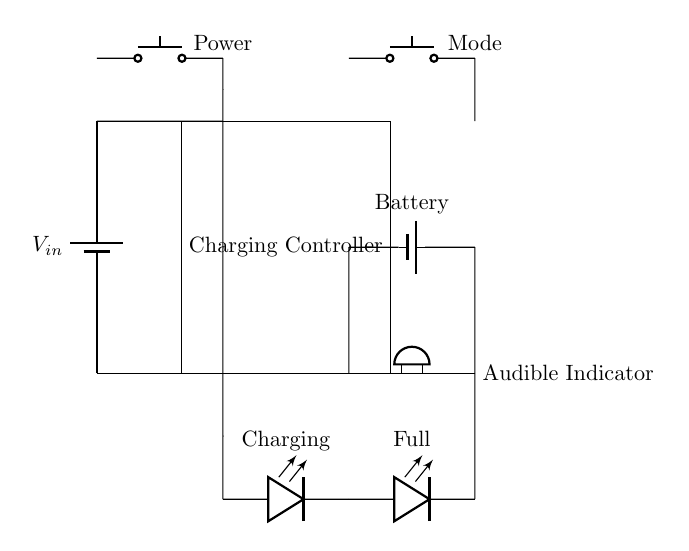What type of power supply is used in this circuit? The circuit uses a battery as its power supply, which is indicated by the symbol labeled as $V_{in}$. A battery provides the necessary voltage and current to charge the hearing aid battery.
Answer: battery How many buttons are present in the circuit? There are two push buttons in the circuit, one labeled as Power and the other labeled as Mode, both located at the top of the diagram.
Answer: two What function does the buzzer serve in this circuit? The buzzer acts as an audible indicator, providing sound feedback regarding the charging status of the battery. Its presence shows that there is an active component to alert the user with sound.
Answer: audible indicator What do the LED indicators represent? The two LED indicators labeled as Charging and Full indicate the status of the battery charging process. The 'Charging' LED lights up when the battery is charging, while the 'Full' LED lights up when the battery is fully charged.
Answer: Charging and Full Which component regulates the charging process? The component that regulates the charging process is the Charging Controller, which manages the flow of electricity from the power supply to the battery, ensuring that it charges safely and effectively.
Answer: Charging Controller What connects the battery to the audible indicator? The battery is connected to the audible indicator through conductive paths shown in the diagram, indicating that it receives power directly from the battery. This connection allows the buzzer to operate whenever needed for alerts.
Answer: conductive paths What does the 'Mode' button control? The Mode button typically allows the user to switch between different settings or operational modes of the charging system, providing flexibility in how the charger operates, such as selecting charging speeds or notifications.
Answer: user settings 